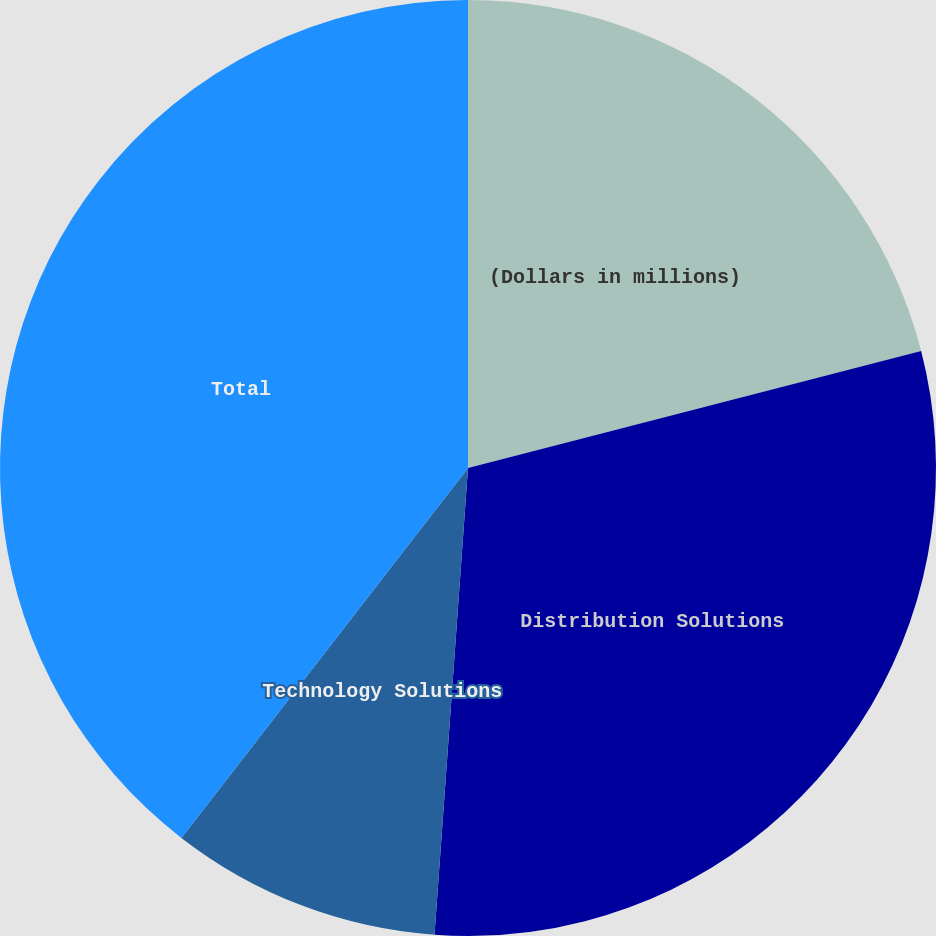Convert chart. <chart><loc_0><loc_0><loc_500><loc_500><pie_chart><fcel>(Dollars in millions)<fcel>Distribution Solutions<fcel>Technology Solutions<fcel>Total<nl><fcel>20.98%<fcel>30.16%<fcel>9.35%<fcel>39.51%<nl></chart> 